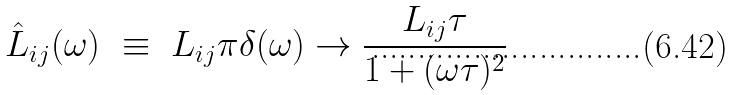<formula> <loc_0><loc_0><loc_500><loc_500>\hat { L } _ { i j } ( \omega ) \ \equiv \ L _ { i j } \pi \delta ( \omega ) \to \frac { L _ { i j } \tau } { 1 + ( \omega \tau ) ^ { 2 } }</formula> 